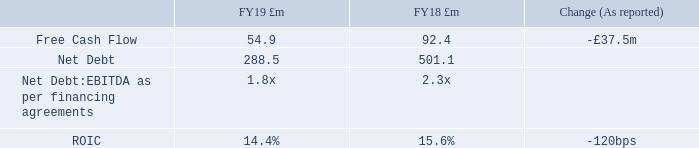Performance
Free Cash Flow was £54.9m in FY19 compared to £92.4m in FY18, the decrease primarily reflecting the impact of US cash flows. This represents a conversion rate of 36% of Adjusted EBITDA (FY18: 45%). Excluding the US cash flows, Free Cash Flow Conversion increased to 47% from 33% in FY18, driven by improved EBITDA, lower working capital outflows, lower interest costs and lower exceptional cashflows.
Several other factors had a specific impact on cash flow during FY19. These included the effects of the disposal of the US business and associated capital restructuring, as well as the timing of dividend payments.
Net Debt decreased to £288.5m from £501.1m at the end of FY18. The Group’s Net Debt:EBITDA leverage as measured under financing agreements was 1.8x at year end. This compared to 1.9x at the end of March 2019 and 2.3x at the end of September 2018. This outturn includes the increased debt associated with the Freshtime acquisition completed in early September 2019. As at 27 September 2019, the Group had committed facilities of £506m with a weighted average maturity of 4.0 years.
ROIC was 14.4% for the 12 months ended 27 September 2019, compared to 15.6% for the 12 months ended 28 September 2018. The reduction was primarily driven by increased investment, in particular the timing of the acquisition of Freshtime and was so impacted by an increased tax rate.
What was the free cash flow in FY19? £54.9m. What factors had a specific impact on cash flow during FY19? The effects of the disposal of the us business and associated capital restructuring, as well as the timing of dividend payments. What was the Net Debt in FY18?  £288.5m. What was the percentage change in the free cash flow from FY18 to FY19?
Answer scale should be: percent. (54.9-92.4)/92.4
Answer: -40.58. What is the average net debt for FY18 and FY19?
Answer scale should be: million. (288.5 + 501.1) / 2
Answer: 394.8. What is the change in the net debt:EBITDA as per financing agreements from FY18 to FY19? 1.8 - 2.3
Answer: -0.5. 